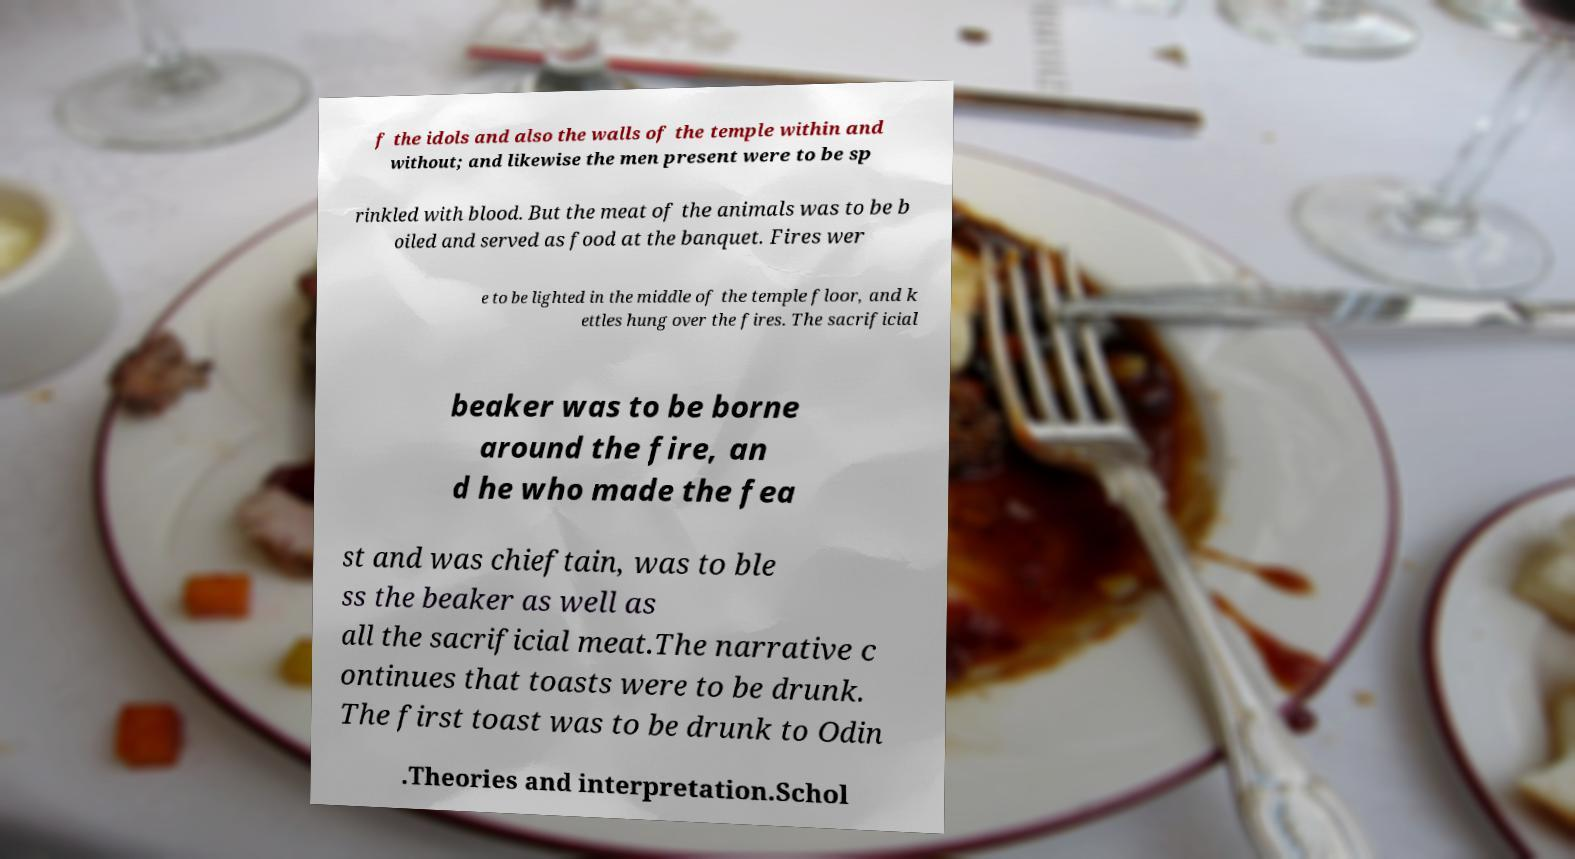There's text embedded in this image that I need extracted. Can you transcribe it verbatim? f the idols and also the walls of the temple within and without; and likewise the men present were to be sp rinkled with blood. But the meat of the animals was to be b oiled and served as food at the banquet. Fires wer e to be lighted in the middle of the temple floor, and k ettles hung over the fires. The sacrificial beaker was to be borne around the fire, an d he who made the fea st and was chieftain, was to ble ss the beaker as well as all the sacrificial meat.The narrative c ontinues that toasts were to be drunk. The first toast was to be drunk to Odin .Theories and interpretation.Schol 